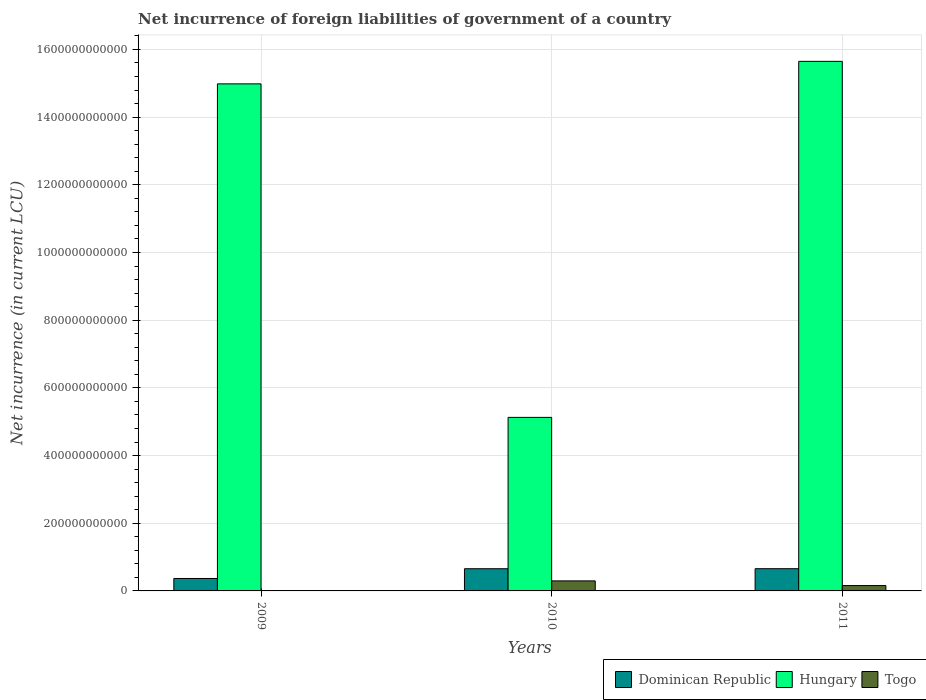How many groups of bars are there?
Provide a succinct answer. 3. Are the number of bars per tick equal to the number of legend labels?
Make the answer very short. No. Are the number of bars on each tick of the X-axis equal?
Offer a very short reply. No. How many bars are there on the 2nd tick from the left?
Your response must be concise. 3. What is the label of the 2nd group of bars from the left?
Offer a very short reply. 2010. In how many cases, is the number of bars for a given year not equal to the number of legend labels?
Ensure brevity in your answer.  1. What is the net incurrence of foreign liabilities in Hungary in 2011?
Offer a very short reply. 1.56e+12. Across all years, what is the maximum net incurrence of foreign liabilities in Hungary?
Give a very brief answer. 1.56e+12. Across all years, what is the minimum net incurrence of foreign liabilities in Dominican Republic?
Ensure brevity in your answer.  3.68e+1. What is the total net incurrence of foreign liabilities in Hungary in the graph?
Your answer should be compact. 3.58e+12. What is the difference between the net incurrence of foreign liabilities in Hungary in 2009 and that in 2011?
Your answer should be compact. -6.65e+1. What is the difference between the net incurrence of foreign liabilities in Hungary in 2010 and the net incurrence of foreign liabilities in Togo in 2009?
Your answer should be very brief. 5.13e+11. What is the average net incurrence of foreign liabilities in Togo per year?
Give a very brief answer. 1.52e+1. In the year 2009, what is the difference between the net incurrence of foreign liabilities in Hungary and net incurrence of foreign liabilities in Dominican Republic?
Provide a succinct answer. 1.46e+12. In how many years, is the net incurrence of foreign liabilities in Togo greater than 200000000000 LCU?
Give a very brief answer. 0. What is the ratio of the net incurrence of foreign liabilities in Hungary in 2009 to that in 2011?
Provide a succinct answer. 0.96. What is the difference between the highest and the second highest net incurrence of foreign liabilities in Dominican Republic?
Give a very brief answer. 7.65e+07. What is the difference between the highest and the lowest net incurrence of foreign liabilities in Togo?
Keep it short and to the point. 2.96e+1. In how many years, is the net incurrence of foreign liabilities in Dominican Republic greater than the average net incurrence of foreign liabilities in Dominican Republic taken over all years?
Make the answer very short. 2. What is the difference between two consecutive major ticks on the Y-axis?
Provide a short and direct response. 2.00e+11. Are the values on the major ticks of Y-axis written in scientific E-notation?
Your answer should be compact. No. Does the graph contain any zero values?
Offer a terse response. Yes. Does the graph contain grids?
Keep it short and to the point. Yes. Where does the legend appear in the graph?
Keep it short and to the point. Bottom right. How are the legend labels stacked?
Make the answer very short. Horizontal. What is the title of the graph?
Offer a terse response. Net incurrence of foreign liabilities of government of a country. What is the label or title of the X-axis?
Provide a succinct answer. Years. What is the label or title of the Y-axis?
Provide a short and direct response. Net incurrence (in current LCU). What is the Net incurrence (in current LCU) in Dominican Republic in 2009?
Make the answer very short. 3.68e+1. What is the Net incurrence (in current LCU) of Hungary in 2009?
Make the answer very short. 1.50e+12. What is the Net incurrence (in current LCU) of Togo in 2009?
Keep it short and to the point. 0. What is the Net incurrence (in current LCU) of Dominican Republic in 2010?
Your answer should be very brief. 6.56e+1. What is the Net incurrence (in current LCU) in Hungary in 2010?
Ensure brevity in your answer.  5.13e+11. What is the Net incurrence (in current LCU) in Togo in 2010?
Your response must be concise. 2.96e+1. What is the Net incurrence (in current LCU) in Dominican Republic in 2011?
Your answer should be compact. 6.57e+1. What is the Net incurrence (in current LCU) in Hungary in 2011?
Keep it short and to the point. 1.56e+12. What is the Net incurrence (in current LCU) of Togo in 2011?
Ensure brevity in your answer.  1.59e+1. Across all years, what is the maximum Net incurrence (in current LCU) in Dominican Republic?
Offer a terse response. 6.57e+1. Across all years, what is the maximum Net incurrence (in current LCU) of Hungary?
Give a very brief answer. 1.56e+12. Across all years, what is the maximum Net incurrence (in current LCU) of Togo?
Offer a terse response. 2.96e+1. Across all years, what is the minimum Net incurrence (in current LCU) in Dominican Republic?
Your answer should be compact. 3.68e+1. Across all years, what is the minimum Net incurrence (in current LCU) in Hungary?
Make the answer very short. 5.13e+11. What is the total Net incurrence (in current LCU) in Dominican Republic in the graph?
Keep it short and to the point. 1.68e+11. What is the total Net incurrence (in current LCU) in Hungary in the graph?
Provide a succinct answer. 3.58e+12. What is the total Net incurrence (in current LCU) of Togo in the graph?
Ensure brevity in your answer.  4.55e+1. What is the difference between the Net incurrence (in current LCU) of Dominican Republic in 2009 and that in 2010?
Offer a very short reply. -2.88e+1. What is the difference between the Net incurrence (in current LCU) of Hungary in 2009 and that in 2010?
Your answer should be compact. 9.85e+11. What is the difference between the Net incurrence (in current LCU) in Dominican Republic in 2009 and that in 2011?
Keep it short and to the point. -2.89e+1. What is the difference between the Net incurrence (in current LCU) in Hungary in 2009 and that in 2011?
Your answer should be very brief. -6.65e+1. What is the difference between the Net incurrence (in current LCU) of Dominican Republic in 2010 and that in 2011?
Make the answer very short. -7.65e+07. What is the difference between the Net incurrence (in current LCU) of Hungary in 2010 and that in 2011?
Provide a succinct answer. -1.05e+12. What is the difference between the Net incurrence (in current LCU) of Togo in 2010 and that in 2011?
Your answer should be compact. 1.38e+1. What is the difference between the Net incurrence (in current LCU) of Dominican Republic in 2009 and the Net incurrence (in current LCU) of Hungary in 2010?
Your response must be concise. -4.76e+11. What is the difference between the Net incurrence (in current LCU) in Dominican Republic in 2009 and the Net incurrence (in current LCU) in Togo in 2010?
Your answer should be compact. 7.14e+09. What is the difference between the Net incurrence (in current LCU) in Hungary in 2009 and the Net incurrence (in current LCU) in Togo in 2010?
Your response must be concise. 1.47e+12. What is the difference between the Net incurrence (in current LCU) in Dominican Republic in 2009 and the Net incurrence (in current LCU) in Hungary in 2011?
Your response must be concise. -1.53e+12. What is the difference between the Net incurrence (in current LCU) of Dominican Republic in 2009 and the Net incurrence (in current LCU) of Togo in 2011?
Ensure brevity in your answer.  2.09e+1. What is the difference between the Net incurrence (in current LCU) in Hungary in 2009 and the Net incurrence (in current LCU) in Togo in 2011?
Your answer should be compact. 1.48e+12. What is the difference between the Net incurrence (in current LCU) in Dominican Republic in 2010 and the Net incurrence (in current LCU) in Hungary in 2011?
Give a very brief answer. -1.50e+12. What is the difference between the Net incurrence (in current LCU) of Dominican Republic in 2010 and the Net incurrence (in current LCU) of Togo in 2011?
Your answer should be compact. 4.97e+1. What is the difference between the Net incurrence (in current LCU) in Hungary in 2010 and the Net incurrence (in current LCU) in Togo in 2011?
Your answer should be very brief. 4.97e+11. What is the average Net incurrence (in current LCU) of Dominican Republic per year?
Make the answer very short. 5.60e+1. What is the average Net incurrence (in current LCU) in Hungary per year?
Provide a succinct answer. 1.19e+12. What is the average Net incurrence (in current LCU) of Togo per year?
Offer a very short reply. 1.52e+1. In the year 2009, what is the difference between the Net incurrence (in current LCU) in Dominican Republic and Net incurrence (in current LCU) in Hungary?
Give a very brief answer. -1.46e+12. In the year 2010, what is the difference between the Net incurrence (in current LCU) of Dominican Republic and Net incurrence (in current LCU) of Hungary?
Offer a terse response. -4.47e+11. In the year 2010, what is the difference between the Net incurrence (in current LCU) in Dominican Republic and Net incurrence (in current LCU) in Togo?
Ensure brevity in your answer.  3.59e+1. In the year 2010, what is the difference between the Net incurrence (in current LCU) of Hungary and Net incurrence (in current LCU) of Togo?
Keep it short and to the point. 4.83e+11. In the year 2011, what is the difference between the Net incurrence (in current LCU) of Dominican Republic and Net incurrence (in current LCU) of Hungary?
Ensure brevity in your answer.  -1.50e+12. In the year 2011, what is the difference between the Net incurrence (in current LCU) of Dominican Republic and Net incurrence (in current LCU) of Togo?
Ensure brevity in your answer.  4.98e+1. In the year 2011, what is the difference between the Net incurrence (in current LCU) of Hungary and Net incurrence (in current LCU) of Togo?
Give a very brief answer. 1.55e+12. What is the ratio of the Net incurrence (in current LCU) of Dominican Republic in 2009 to that in 2010?
Your response must be concise. 0.56. What is the ratio of the Net incurrence (in current LCU) of Hungary in 2009 to that in 2010?
Offer a very short reply. 2.92. What is the ratio of the Net incurrence (in current LCU) of Dominican Republic in 2009 to that in 2011?
Your answer should be compact. 0.56. What is the ratio of the Net incurrence (in current LCU) of Hungary in 2009 to that in 2011?
Offer a terse response. 0.96. What is the ratio of the Net incurrence (in current LCU) in Dominican Republic in 2010 to that in 2011?
Ensure brevity in your answer.  1. What is the ratio of the Net incurrence (in current LCU) in Hungary in 2010 to that in 2011?
Provide a succinct answer. 0.33. What is the ratio of the Net incurrence (in current LCU) in Togo in 2010 to that in 2011?
Provide a succinct answer. 1.87. What is the difference between the highest and the second highest Net incurrence (in current LCU) in Dominican Republic?
Offer a terse response. 7.65e+07. What is the difference between the highest and the second highest Net incurrence (in current LCU) of Hungary?
Your response must be concise. 6.65e+1. What is the difference between the highest and the lowest Net incurrence (in current LCU) in Dominican Republic?
Provide a succinct answer. 2.89e+1. What is the difference between the highest and the lowest Net incurrence (in current LCU) in Hungary?
Offer a very short reply. 1.05e+12. What is the difference between the highest and the lowest Net incurrence (in current LCU) of Togo?
Give a very brief answer. 2.96e+1. 